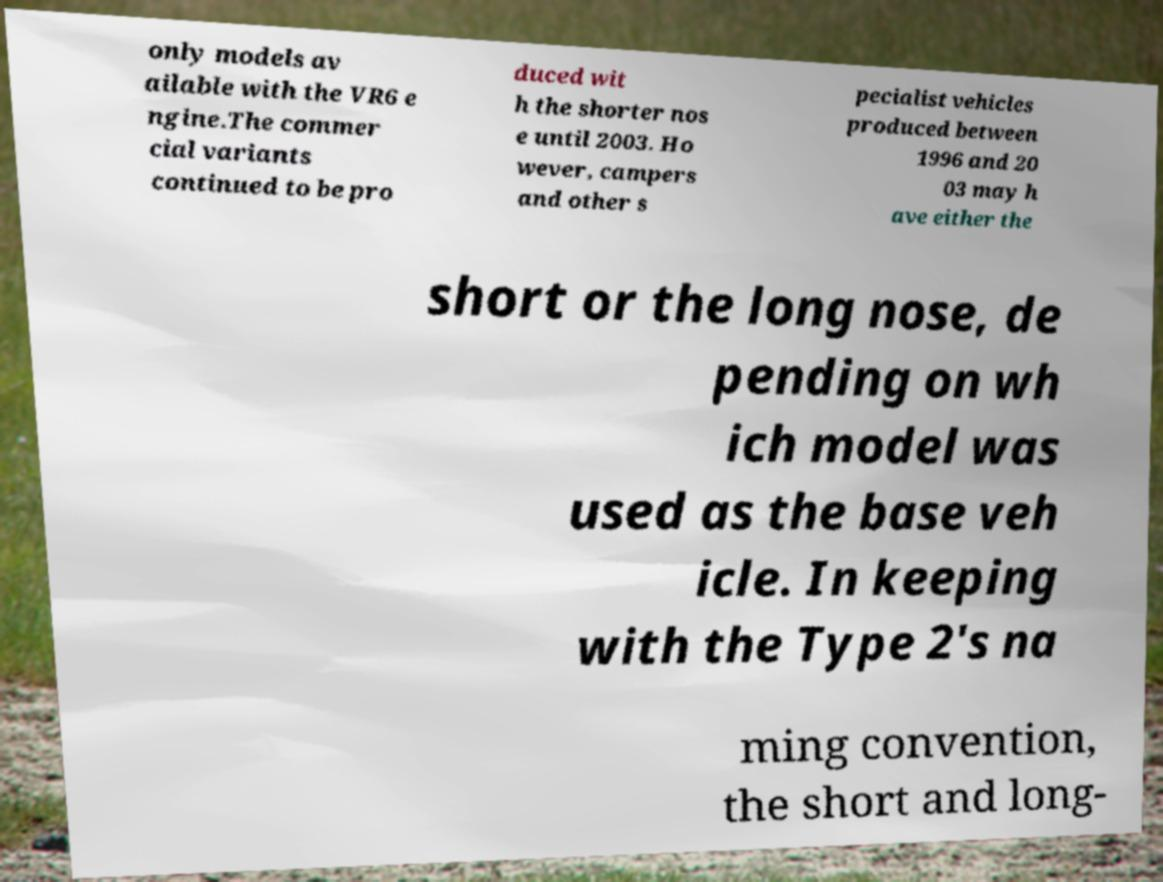Please read and relay the text visible in this image. What does it say? only models av ailable with the VR6 e ngine.The commer cial variants continued to be pro duced wit h the shorter nos e until 2003. Ho wever, campers and other s pecialist vehicles produced between 1996 and 20 03 may h ave either the short or the long nose, de pending on wh ich model was used as the base veh icle. In keeping with the Type 2's na ming convention, the short and long- 